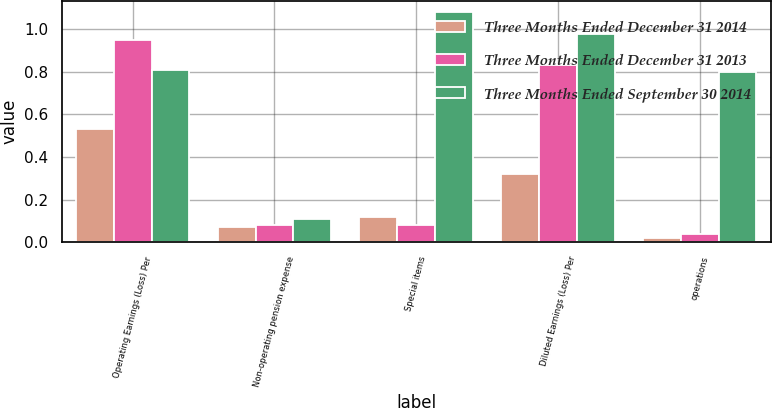Convert chart. <chart><loc_0><loc_0><loc_500><loc_500><stacked_bar_chart><ecel><fcel>Operating Earnings (Loss) Per<fcel>Non-operating pension expense<fcel>Special items<fcel>Diluted Earnings (Loss) Per<fcel>operations<nl><fcel>Three Months Ended December 31 2014<fcel>0.53<fcel>0.07<fcel>0.12<fcel>0.32<fcel>0.02<nl><fcel>Three Months Ended December 31 2013<fcel>0.95<fcel>0.08<fcel>0.08<fcel>0.83<fcel>0.04<nl><fcel>Three Months Ended September 30 2014<fcel>0.81<fcel>0.11<fcel>1.08<fcel>0.98<fcel>0.8<nl></chart> 